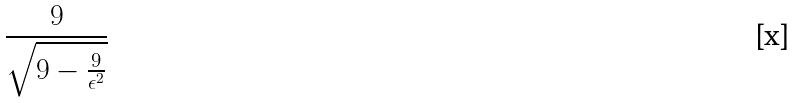Convert formula to latex. <formula><loc_0><loc_0><loc_500><loc_500>\frac { 9 } { \sqrt { 9 - \frac { 9 } { \epsilon ^ { 2 } } } }</formula> 